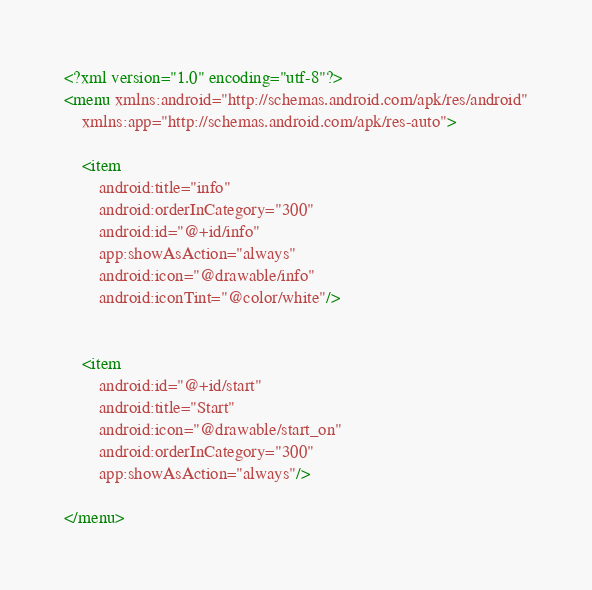<code> <loc_0><loc_0><loc_500><loc_500><_XML_><?xml version="1.0" encoding="utf-8"?>
<menu xmlns:android="http://schemas.android.com/apk/res/android"
    xmlns:app="http://schemas.android.com/apk/res-auto">

    <item
        android:title="info"
        android:orderInCategory="300"
        android:id="@+id/info"
        app:showAsAction="always"
        android:icon="@drawable/info"
        android:iconTint="@color/white"/>


    <item
        android:id="@+id/start"
        android:title="Start"
        android:icon="@drawable/start_on"
        android:orderInCategory="300"
        app:showAsAction="always"/>

</menu></code> 